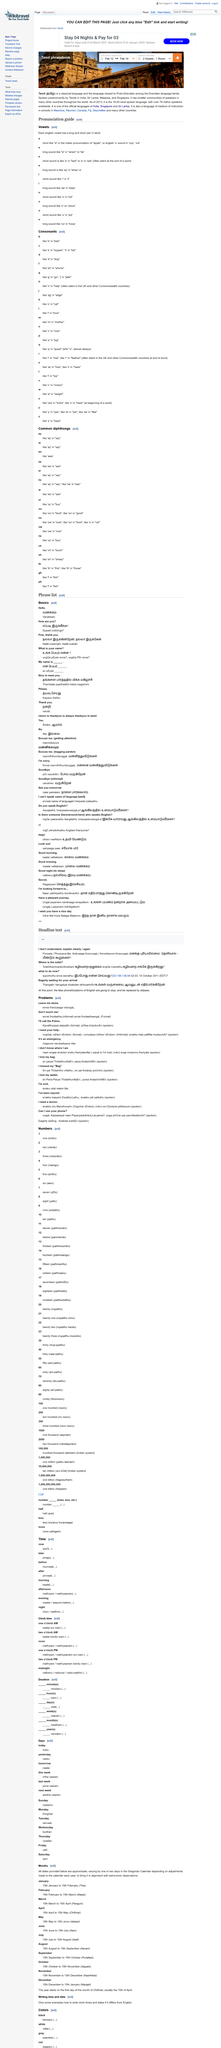Highlight a few significant elements in this photo. According to the "Tamil phrasebook", Tamil is a classical language and is the closest to Proto-Dravidian among the Dravidian language family. It is being reported that 1 room is currently being booked. It is being reported that two guests are currently staying. 